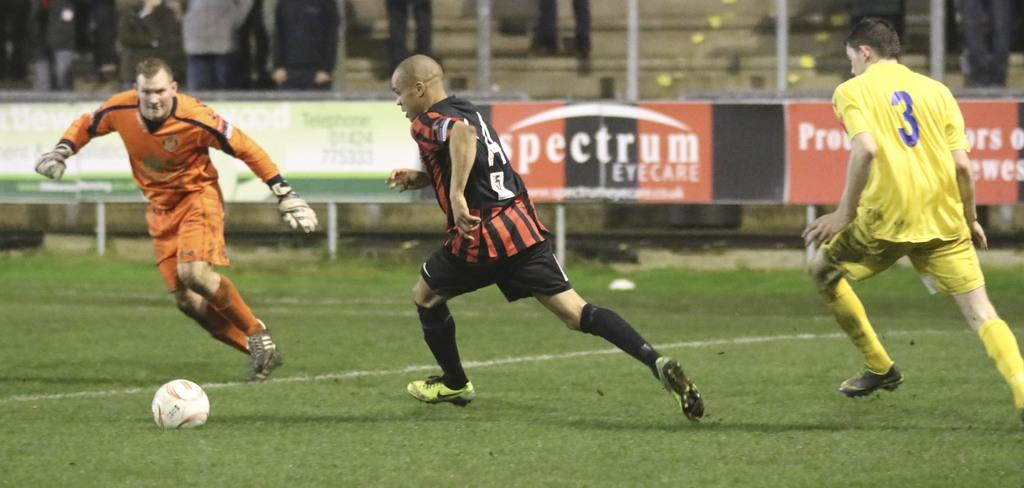<image>
Share a concise interpretation of the image provided. Player number 3 on the yellow team isn't close enough to steal the ball from the orange player. 